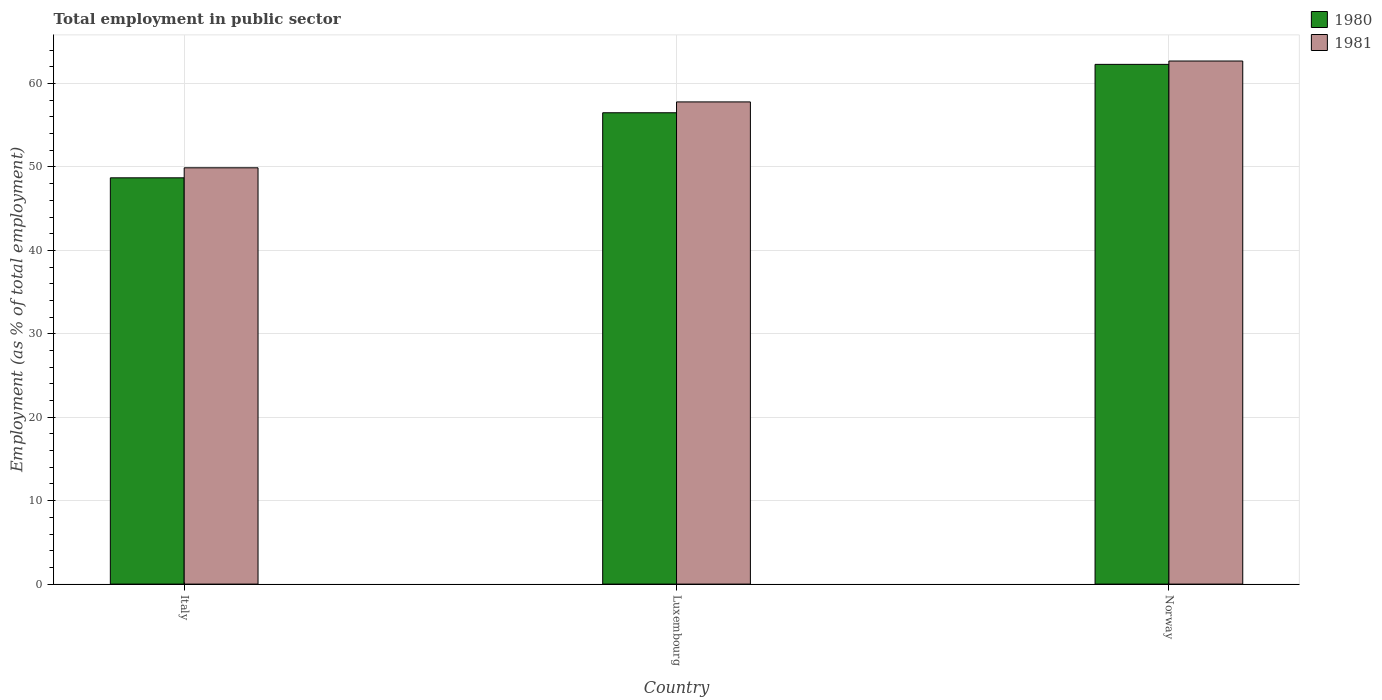Are the number of bars per tick equal to the number of legend labels?
Provide a short and direct response. Yes. How many bars are there on the 3rd tick from the right?
Provide a succinct answer. 2. What is the label of the 3rd group of bars from the left?
Give a very brief answer. Norway. In how many cases, is the number of bars for a given country not equal to the number of legend labels?
Offer a very short reply. 0. What is the employment in public sector in 1980 in Italy?
Ensure brevity in your answer.  48.7. Across all countries, what is the maximum employment in public sector in 1981?
Offer a terse response. 62.7. Across all countries, what is the minimum employment in public sector in 1981?
Your response must be concise. 49.9. In which country was the employment in public sector in 1981 minimum?
Make the answer very short. Italy. What is the total employment in public sector in 1980 in the graph?
Provide a short and direct response. 167.5. What is the difference between the employment in public sector in 1980 in Italy and that in Luxembourg?
Your response must be concise. -7.8. What is the difference between the employment in public sector in 1980 in Luxembourg and the employment in public sector in 1981 in Norway?
Keep it short and to the point. -6.2. What is the average employment in public sector in 1980 per country?
Ensure brevity in your answer.  55.83. What is the difference between the employment in public sector of/in 1980 and employment in public sector of/in 1981 in Italy?
Your answer should be very brief. -1.2. In how many countries, is the employment in public sector in 1980 greater than 38 %?
Ensure brevity in your answer.  3. What is the ratio of the employment in public sector in 1980 in Italy to that in Norway?
Make the answer very short. 0.78. Is the employment in public sector in 1981 in Italy less than that in Luxembourg?
Your response must be concise. Yes. What is the difference between the highest and the second highest employment in public sector in 1981?
Your response must be concise. -4.9. What is the difference between the highest and the lowest employment in public sector in 1981?
Provide a short and direct response. 12.8. In how many countries, is the employment in public sector in 1980 greater than the average employment in public sector in 1980 taken over all countries?
Provide a short and direct response. 2. What does the 1st bar from the right in Italy represents?
Provide a succinct answer. 1981. How many bars are there?
Keep it short and to the point. 6. Are all the bars in the graph horizontal?
Offer a very short reply. No. How many countries are there in the graph?
Offer a terse response. 3. What is the difference between two consecutive major ticks on the Y-axis?
Provide a succinct answer. 10. Are the values on the major ticks of Y-axis written in scientific E-notation?
Your answer should be compact. No. Does the graph contain any zero values?
Make the answer very short. No. Does the graph contain grids?
Your answer should be very brief. Yes. Where does the legend appear in the graph?
Provide a succinct answer. Top right. How many legend labels are there?
Offer a terse response. 2. How are the legend labels stacked?
Offer a terse response. Vertical. What is the title of the graph?
Provide a short and direct response. Total employment in public sector. What is the label or title of the Y-axis?
Your response must be concise. Employment (as % of total employment). What is the Employment (as % of total employment) of 1980 in Italy?
Your answer should be very brief. 48.7. What is the Employment (as % of total employment) in 1981 in Italy?
Make the answer very short. 49.9. What is the Employment (as % of total employment) of 1980 in Luxembourg?
Your response must be concise. 56.5. What is the Employment (as % of total employment) of 1981 in Luxembourg?
Give a very brief answer. 57.8. What is the Employment (as % of total employment) in 1980 in Norway?
Give a very brief answer. 62.3. What is the Employment (as % of total employment) in 1981 in Norway?
Offer a terse response. 62.7. Across all countries, what is the maximum Employment (as % of total employment) of 1980?
Your response must be concise. 62.3. Across all countries, what is the maximum Employment (as % of total employment) in 1981?
Give a very brief answer. 62.7. Across all countries, what is the minimum Employment (as % of total employment) in 1980?
Keep it short and to the point. 48.7. Across all countries, what is the minimum Employment (as % of total employment) of 1981?
Make the answer very short. 49.9. What is the total Employment (as % of total employment) of 1980 in the graph?
Your answer should be compact. 167.5. What is the total Employment (as % of total employment) in 1981 in the graph?
Offer a terse response. 170.4. What is the average Employment (as % of total employment) in 1980 per country?
Offer a very short reply. 55.83. What is the average Employment (as % of total employment) in 1981 per country?
Your answer should be very brief. 56.8. What is the difference between the Employment (as % of total employment) in 1980 and Employment (as % of total employment) in 1981 in Italy?
Provide a short and direct response. -1.2. What is the ratio of the Employment (as % of total employment) in 1980 in Italy to that in Luxembourg?
Offer a terse response. 0.86. What is the ratio of the Employment (as % of total employment) of 1981 in Italy to that in Luxembourg?
Offer a very short reply. 0.86. What is the ratio of the Employment (as % of total employment) of 1980 in Italy to that in Norway?
Ensure brevity in your answer.  0.78. What is the ratio of the Employment (as % of total employment) in 1981 in Italy to that in Norway?
Offer a terse response. 0.8. What is the ratio of the Employment (as % of total employment) in 1980 in Luxembourg to that in Norway?
Ensure brevity in your answer.  0.91. What is the ratio of the Employment (as % of total employment) in 1981 in Luxembourg to that in Norway?
Your answer should be compact. 0.92. 